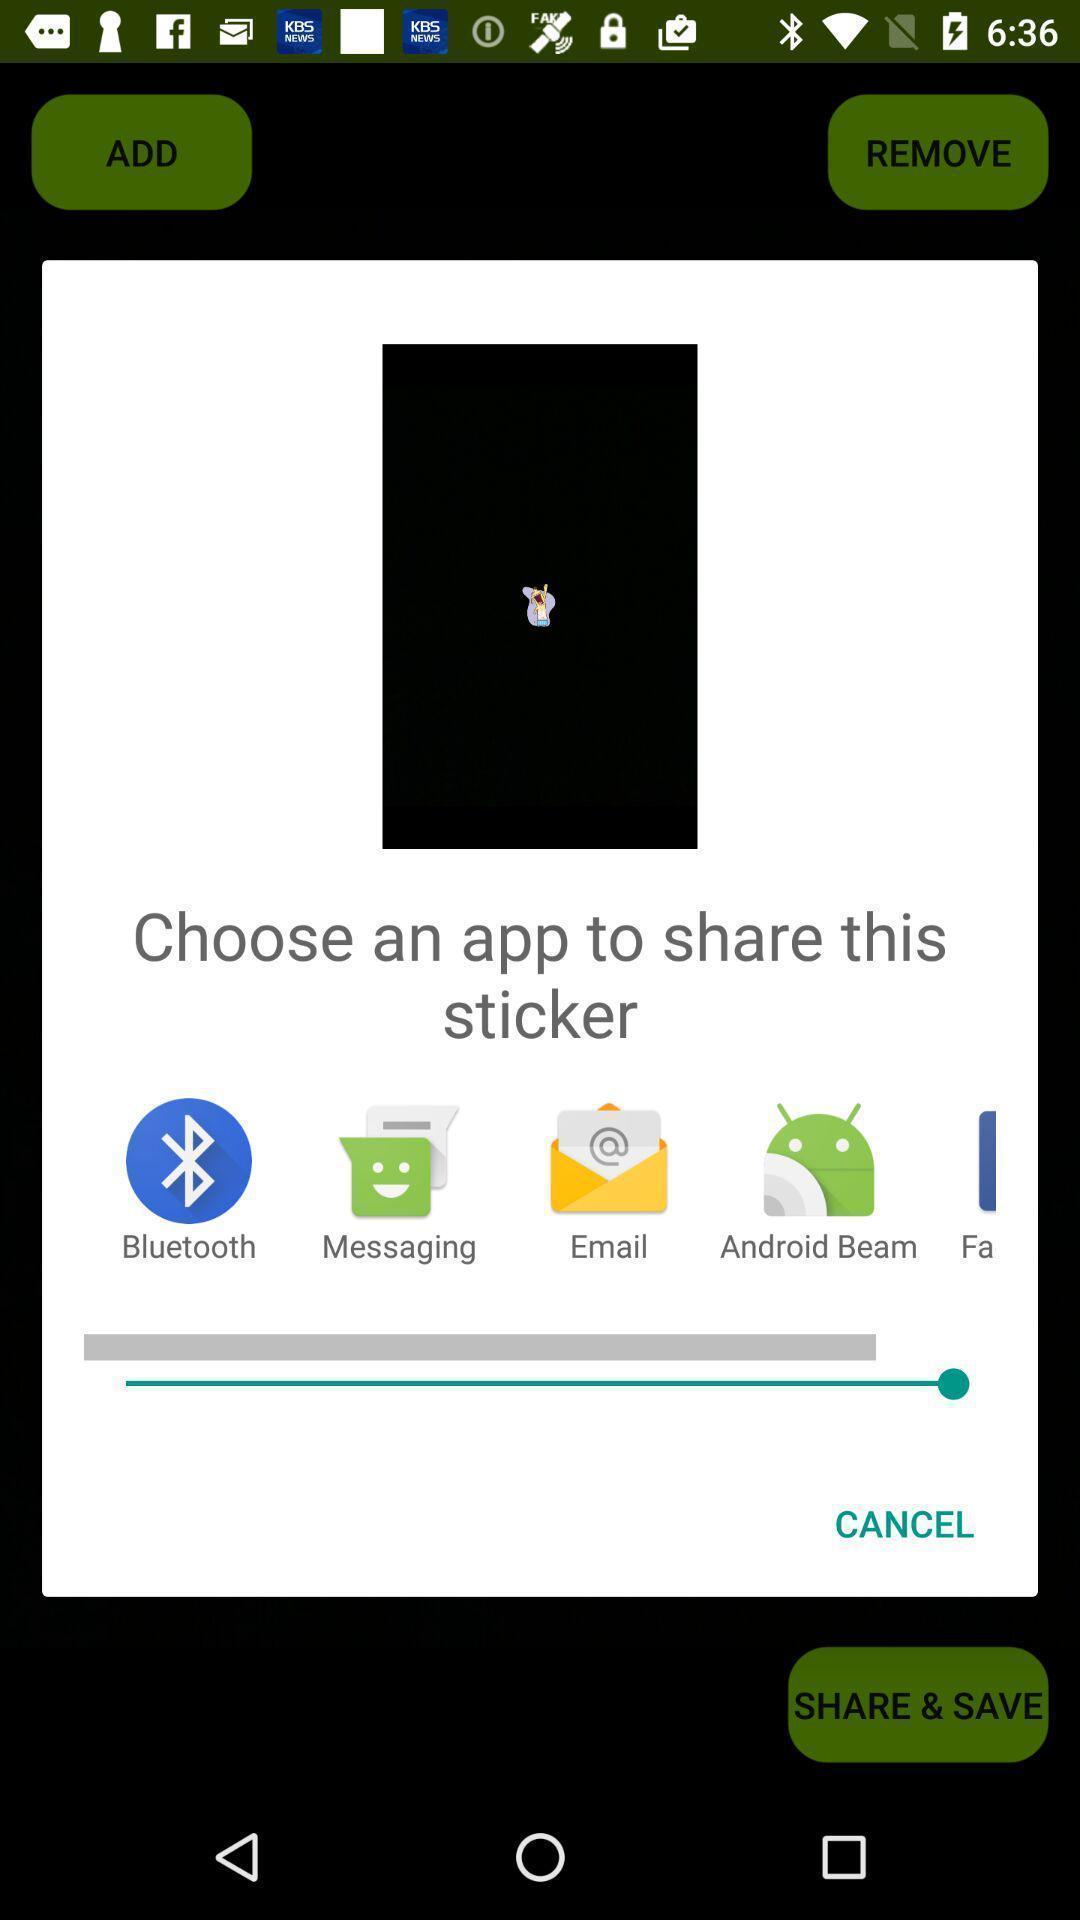Describe the visual elements of this screenshot. Pop-up showing various applications to share. 